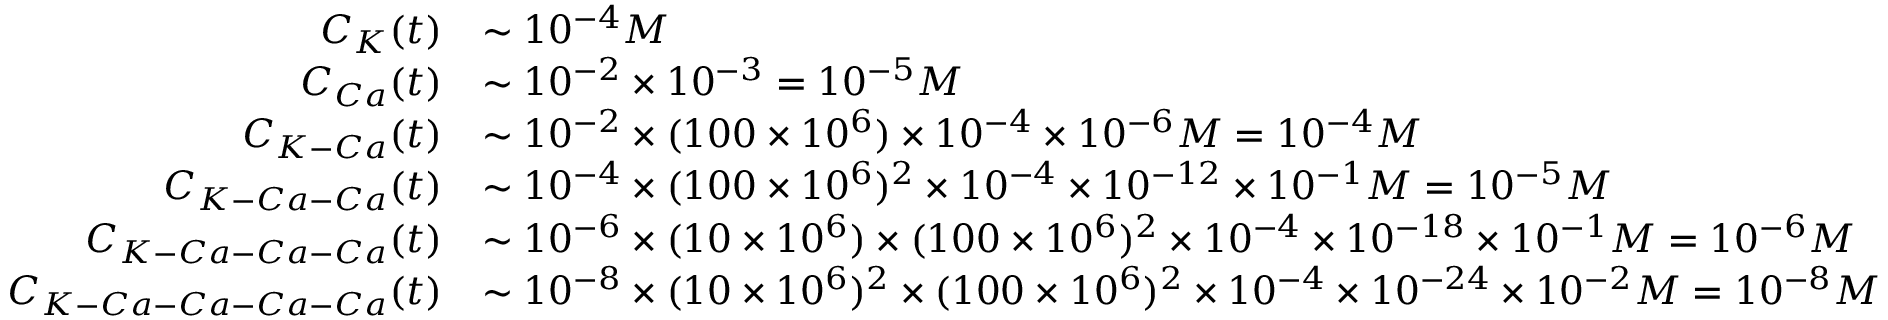Convert formula to latex. <formula><loc_0><loc_0><loc_500><loc_500>\begin{array} { r l } { C _ { K } ( t ) } & { \sim 1 0 ^ { - 4 } M } \\ { C _ { C a } ( t ) } & { \sim 1 0 ^ { - 2 } \times 1 0 ^ { - 3 } = 1 0 ^ { - 5 } M } \\ { C _ { K - C a } ( t ) } & { \sim 1 0 ^ { - 2 } \times ( 1 0 0 \times 1 0 ^ { 6 } ) \times 1 0 ^ { - 4 } \times 1 0 ^ { - 6 } M = 1 0 ^ { - 4 } M } \\ { C _ { K - C a - C a } ( t ) } & { \sim 1 0 ^ { - 4 } \times ( 1 0 0 \times 1 0 ^ { 6 } ) ^ { 2 } \times 1 0 ^ { - 4 } \times 1 0 ^ { - 1 2 } \times 1 0 ^ { - 1 } M = 1 0 ^ { - 5 } M } \\ { C _ { K - C a - C a - C a } ( t ) } & { \sim 1 0 ^ { - 6 } \times ( 1 0 \times 1 0 ^ { 6 } ) \times ( 1 0 0 \times 1 0 ^ { 6 } ) ^ { 2 } \times 1 0 ^ { - 4 } \times 1 0 ^ { - 1 8 } \times 1 0 ^ { - 1 } M = 1 0 ^ { - 6 } M } \\ { C _ { K - C a - C a - C a - C a } ( t ) } & { \sim 1 0 ^ { - 8 } \times ( 1 0 \times 1 0 ^ { 6 } ) ^ { 2 } \times ( 1 0 0 \times 1 0 ^ { 6 } ) ^ { 2 } \times 1 0 ^ { - 4 } \times 1 0 ^ { - 2 4 } \times 1 0 ^ { - 2 } M = 1 0 ^ { - 8 } M } \end{array}</formula> 